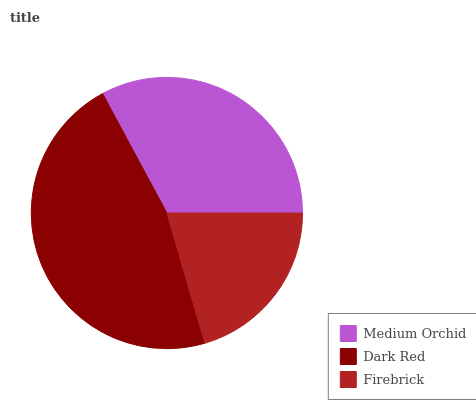Is Firebrick the minimum?
Answer yes or no. Yes. Is Dark Red the maximum?
Answer yes or no. Yes. Is Dark Red the minimum?
Answer yes or no. No. Is Firebrick the maximum?
Answer yes or no. No. Is Dark Red greater than Firebrick?
Answer yes or no. Yes. Is Firebrick less than Dark Red?
Answer yes or no. Yes. Is Firebrick greater than Dark Red?
Answer yes or no. No. Is Dark Red less than Firebrick?
Answer yes or no. No. Is Medium Orchid the high median?
Answer yes or no. Yes. Is Medium Orchid the low median?
Answer yes or no. Yes. Is Firebrick the high median?
Answer yes or no. No. Is Dark Red the low median?
Answer yes or no. No. 